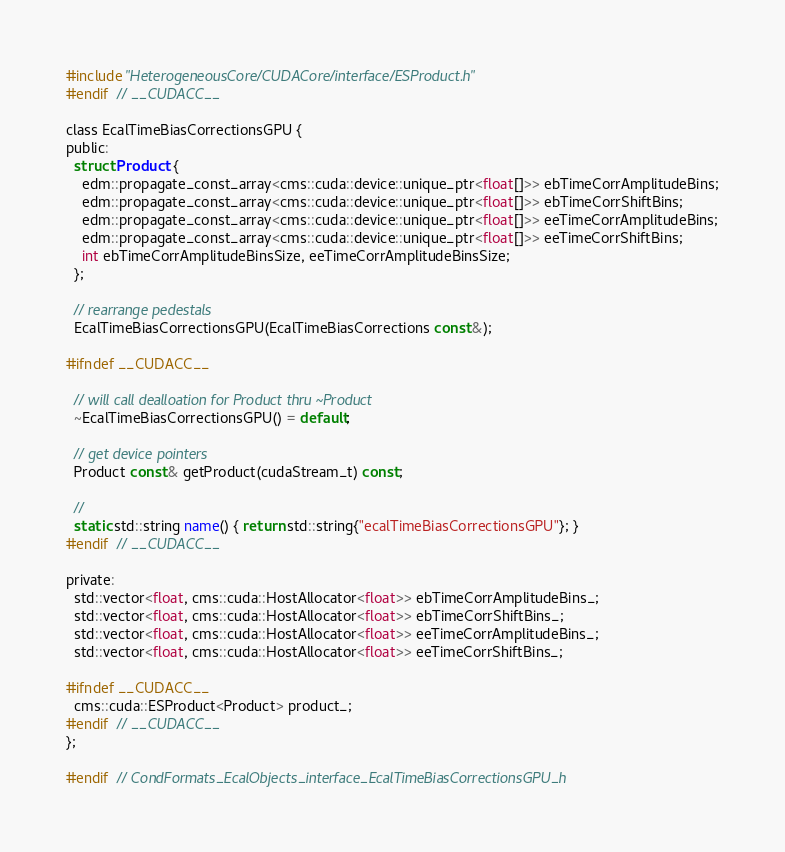<code> <loc_0><loc_0><loc_500><loc_500><_C_>#include "HeterogeneousCore/CUDACore/interface/ESProduct.h"
#endif  // __CUDACC__

class EcalTimeBiasCorrectionsGPU {
public:
  struct Product {
    edm::propagate_const_array<cms::cuda::device::unique_ptr<float[]>> ebTimeCorrAmplitudeBins;
    edm::propagate_const_array<cms::cuda::device::unique_ptr<float[]>> ebTimeCorrShiftBins;
    edm::propagate_const_array<cms::cuda::device::unique_ptr<float[]>> eeTimeCorrAmplitudeBins;
    edm::propagate_const_array<cms::cuda::device::unique_ptr<float[]>> eeTimeCorrShiftBins;
    int ebTimeCorrAmplitudeBinsSize, eeTimeCorrAmplitudeBinsSize;
  };

  // rearrange pedestals
  EcalTimeBiasCorrectionsGPU(EcalTimeBiasCorrections const&);

#ifndef __CUDACC__

  // will call dealloation for Product thru ~Product
  ~EcalTimeBiasCorrectionsGPU() = default;

  // get device pointers
  Product const& getProduct(cudaStream_t) const;

  //
  static std::string name() { return std::string{"ecalTimeBiasCorrectionsGPU"}; }
#endif  // __CUDACC__

private:
  std::vector<float, cms::cuda::HostAllocator<float>> ebTimeCorrAmplitudeBins_;
  std::vector<float, cms::cuda::HostAllocator<float>> ebTimeCorrShiftBins_;
  std::vector<float, cms::cuda::HostAllocator<float>> eeTimeCorrAmplitudeBins_;
  std::vector<float, cms::cuda::HostAllocator<float>> eeTimeCorrShiftBins_;

#ifndef __CUDACC__
  cms::cuda::ESProduct<Product> product_;
#endif  // __CUDACC__
};

#endif  // CondFormats_EcalObjects_interface_EcalTimeBiasCorrectionsGPU_h
</code> 